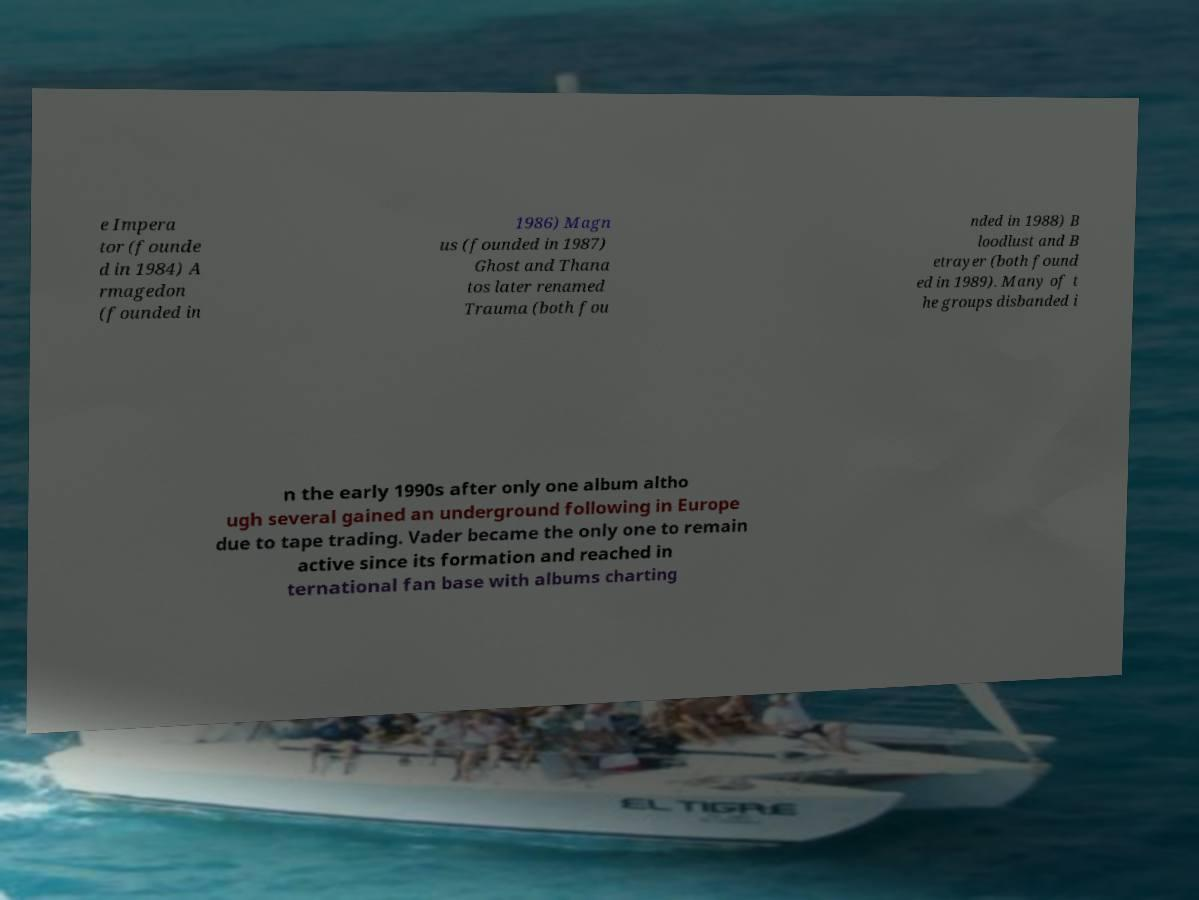Please read and relay the text visible in this image. What does it say? e Impera tor (founde d in 1984) A rmagedon (founded in 1986) Magn us (founded in 1987) Ghost and Thana tos later renamed Trauma (both fou nded in 1988) B loodlust and B etrayer (both found ed in 1989). Many of t he groups disbanded i n the early 1990s after only one album altho ugh several gained an underground following in Europe due to tape trading. Vader became the only one to remain active since its formation and reached in ternational fan base with albums charting 